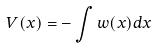<formula> <loc_0><loc_0><loc_500><loc_500>V ( x ) = - \int w ( x ) d x</formula> 